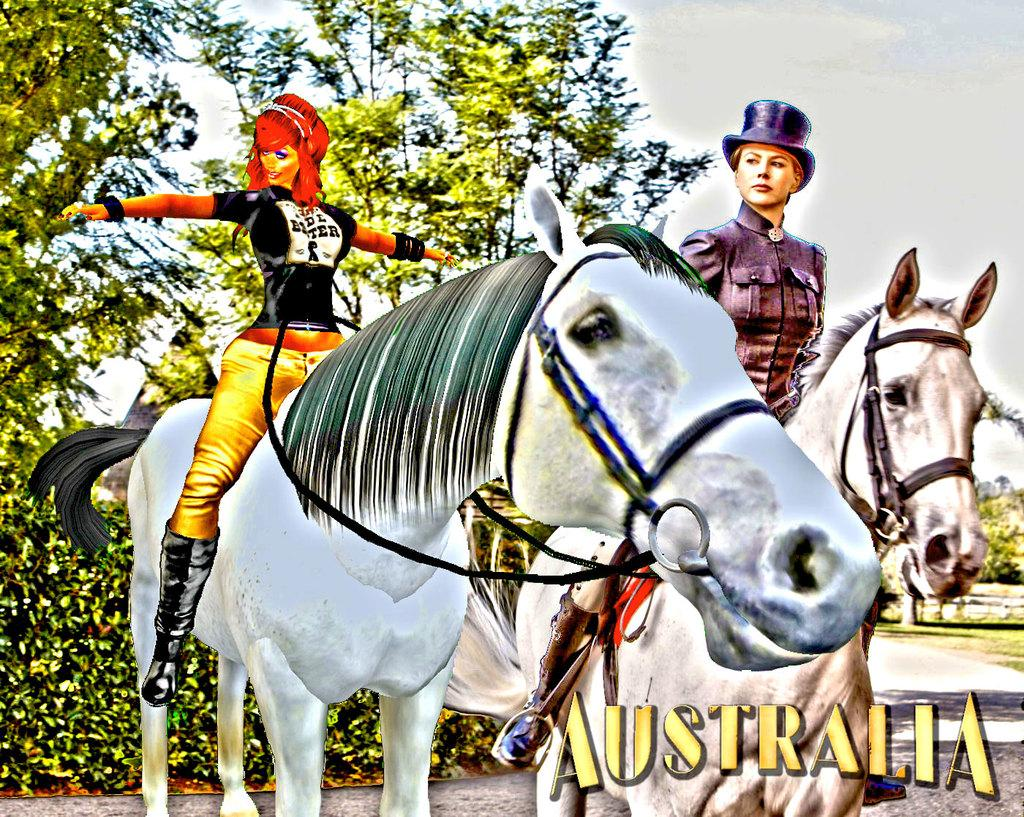What are the women in the animation doing? The women in the animation are sitting on horses. What type of path can be seen in the animation? There is a road in the animation. What type of vegetation is present in the animation? There are bushes and trees in the animation. What is visible in the sky in the animation? The sky is visible in the animation, with clouds present. Can you hear the bell ringing in the animation? There is no mention of a bell in the animation, so it cannot be heard. Is there any sleet falling in the animation? There is no mention of sleet in the animation, so it is not present. 